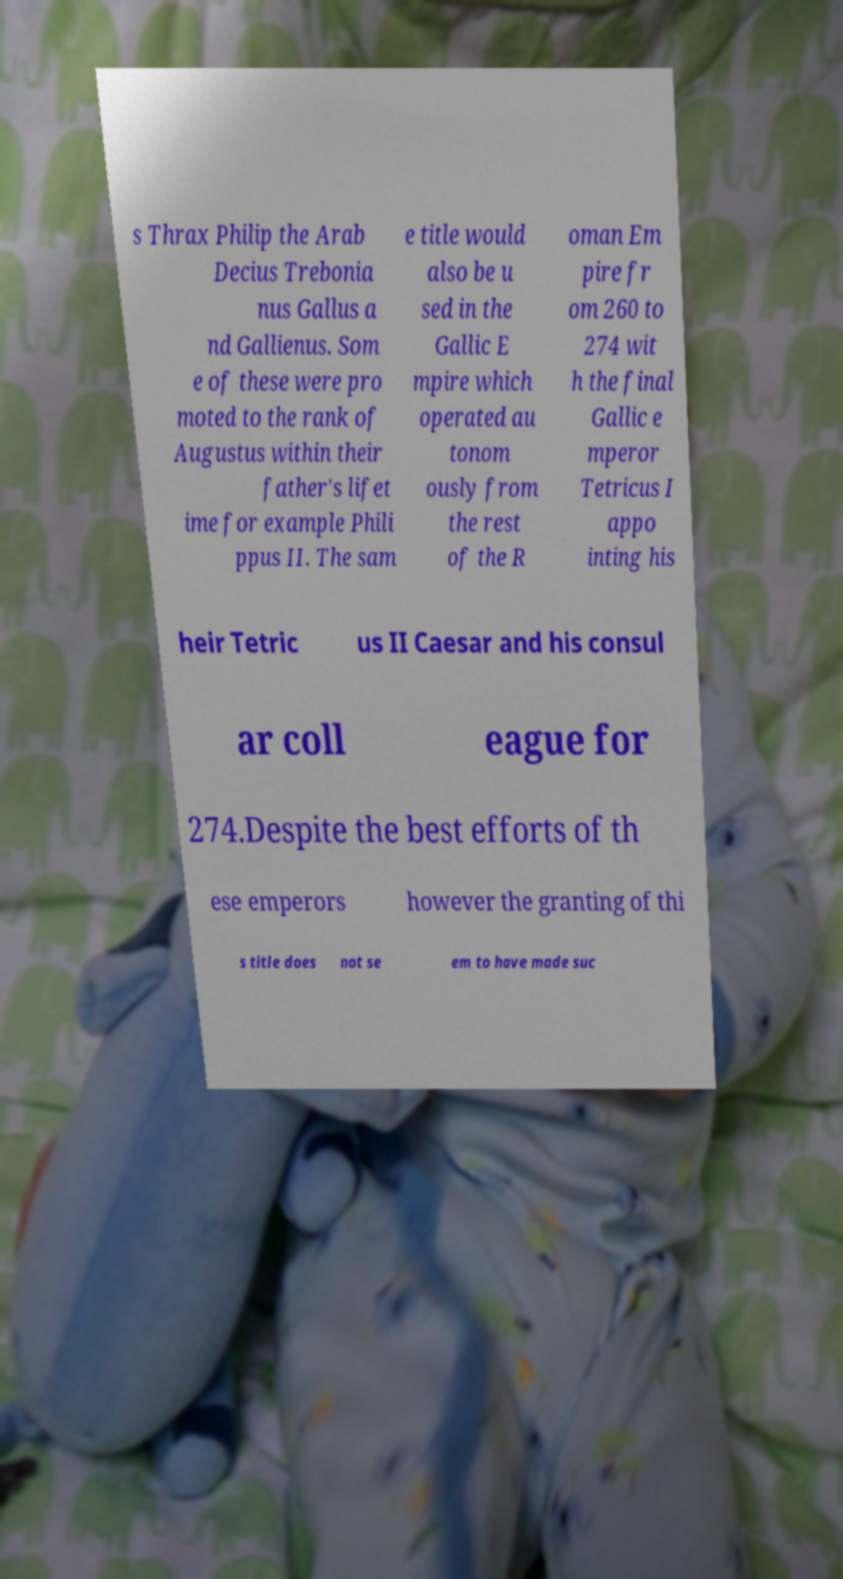I need the written content from this picture converted into text. Can you do that? s Thrax Philip the Arab Decius Trebonia nus Gallus a nd Gallienus. Som e of these were pro moted to the rank of Augustus within their father's lifet ime for example Phili ppus II. The sam e title would also be u sed in the Gallic E mpire which operated au tonom ously from the rest of the R oman Em pire fr om 260 to 274 wit h the final Gallic e mperor Tetricus I appo inting his heir Tetric us II Caesar and his consul ar coll eague for 274.Despite the best efforts of th ese emperors however the granting of thi s title does not se em to have made suc 